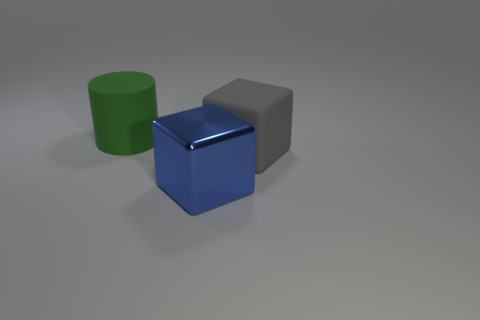What color is the rubber cylinder?
Make the answer very short. Green. How many large gray objects have the same shape as the green rubber object?
Give a very brief answer. 0. What is the color of the other cube that is the same size as the gray matte block?
Make the answer very short. Blue. Is there a tiny metal thing?
Give a very brief answer. No. There is a rubber thing in front of the green thing; what shape is it?
Offer a terse response. Cube. What number of big matte objects are on the left side of the large blue thing and in front of the big cylinder?
Provide a short and direct response. 0. Are there any gray objects made of the same material as the green cylinder?
Provide a succinct answer. Yes. What number of spheres are green things or small yellow rubber objects?
Offer a very short reply. 0. The green cylinder has what size?
Your answer should be compact. Large. How many big green matte objects are in front of the big shiny object?
Offer a very short reply. 0. 